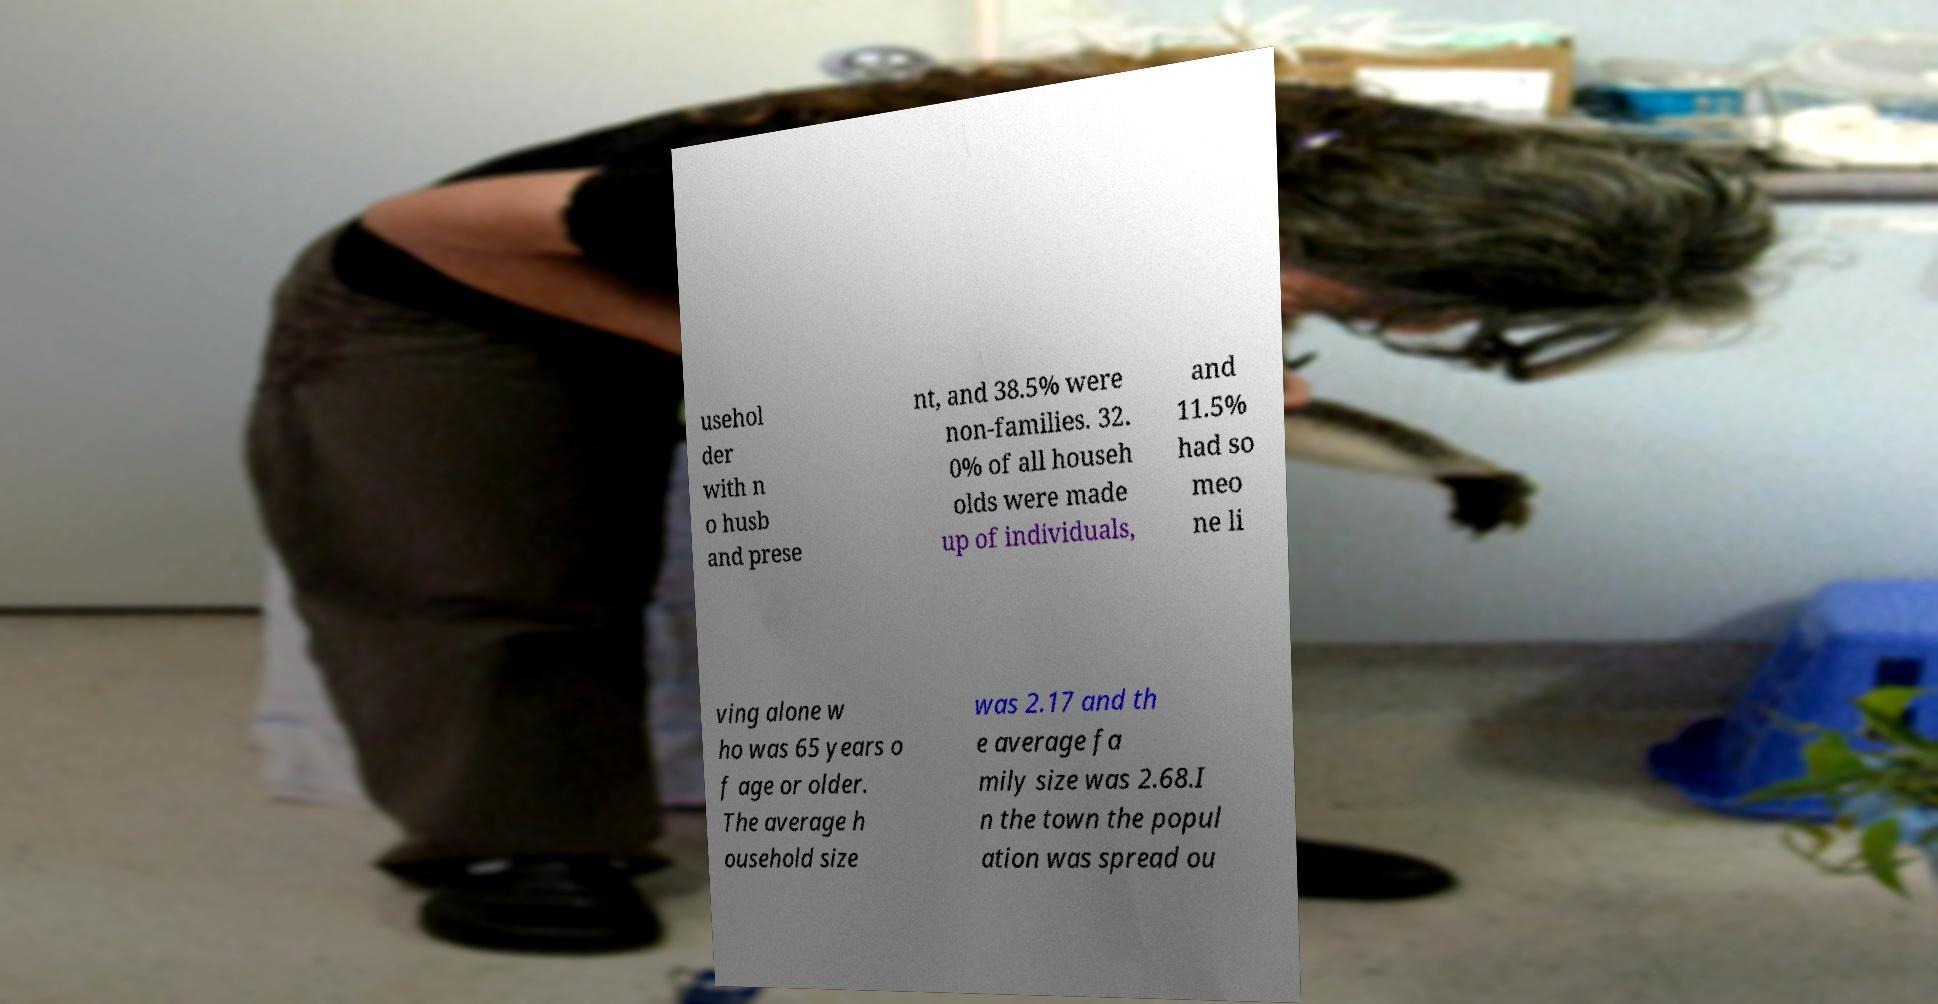Could you extract and type out the text from this image? usehol der with n o husb and prese nt, and 38.5% were non-families. 32. 0% of all househ olds were made up of individuals, and 11.5% had so meo ne li ving alone w ho was 65 years o f age or older. The average h ousehold size was 2.17 and th e average fa mily size was 2.68.I n the town the popul ation was spread ou 